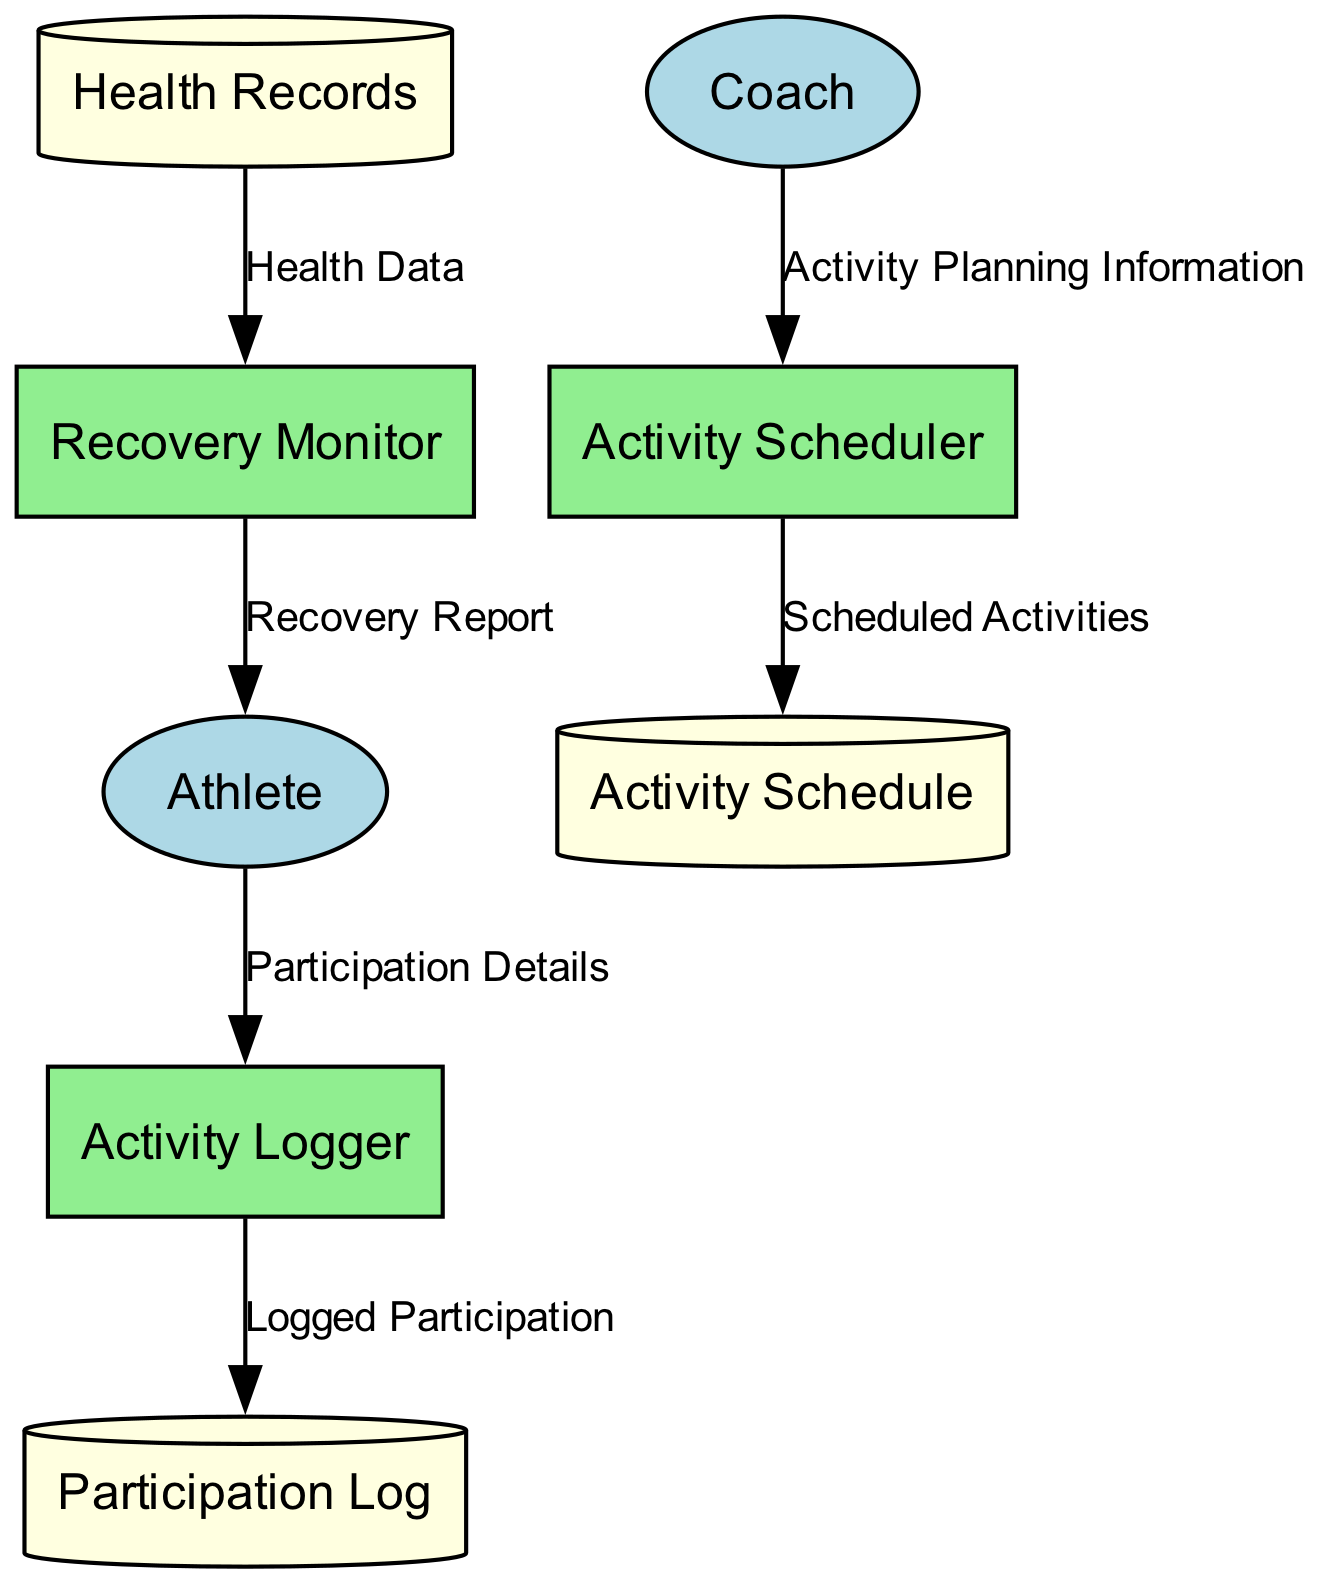What is the name of the process that manages the scheduling of recreational activities? The diagram indicates that the process responsible for managing scheduling is called "Activity Scheduler". By locating the process nodes in the diagram, we can directly identify this specific one.
Answer: Activity Scheduler How many external entities are present in the diagram? By examining the diagram, we see a total of two external entities: "Athlete" and "Coach". This count is obtained by counting the distinct entities labeled as external entities.
Answer: 2 Which data store contains health records related to the athlete? The diagram identifies the data store that holds this information as "Health Records". By checking the data store nodes and their corresponding names, we can confirm this.
Answer: Health Records What flows from the "Recovery Monitor" to the "Athlete"? According to the diagram, the flow from "Recovery Monitor" to "Athlete" includes a "Recovery Report". This can be determined by looking at the outgoing data flows from the "Recovery Monitor" process.
Answer: Recovery Report Who inputs data into the "Activity Logger"? The input data into the "Activity Logger" comes from the "Athlete". This is evident as the diagram shows the arrow pointing from "Athlete" to "Activity Logger" with labeled data flow.
Answer: Athlete Which process outputs the "Participation Log"? The diagram shows that the "Activity Logger" process outputs the "Participation Log". By following the output arrows from this process, we can identify this direct relationship.
Answer: Activity Logger What type of data store is "Participation Log"? The "Participation Log" is categorized as a data store, specifically depicted as a cylinder in the diagram. The visual representation indicates its classification.
Answer: Data Store What input does the "Recovery Monitor" require? The "Recovery Monitor" requires "Health Records" as input. We can observe the input arrow pointing towards "Recovery Monitor" with "Health Data" coming from "Health Records".
Answer: Health Records What kind of information does the "Activity Scheduler" produce? The "Activity Scheduler" generates "Scheduled Activities", which is the output specified in the diagram. This can be confirmed by looking at the output labeled from the "Activity Scheduler" process.
Answer: Scheduled Activities 